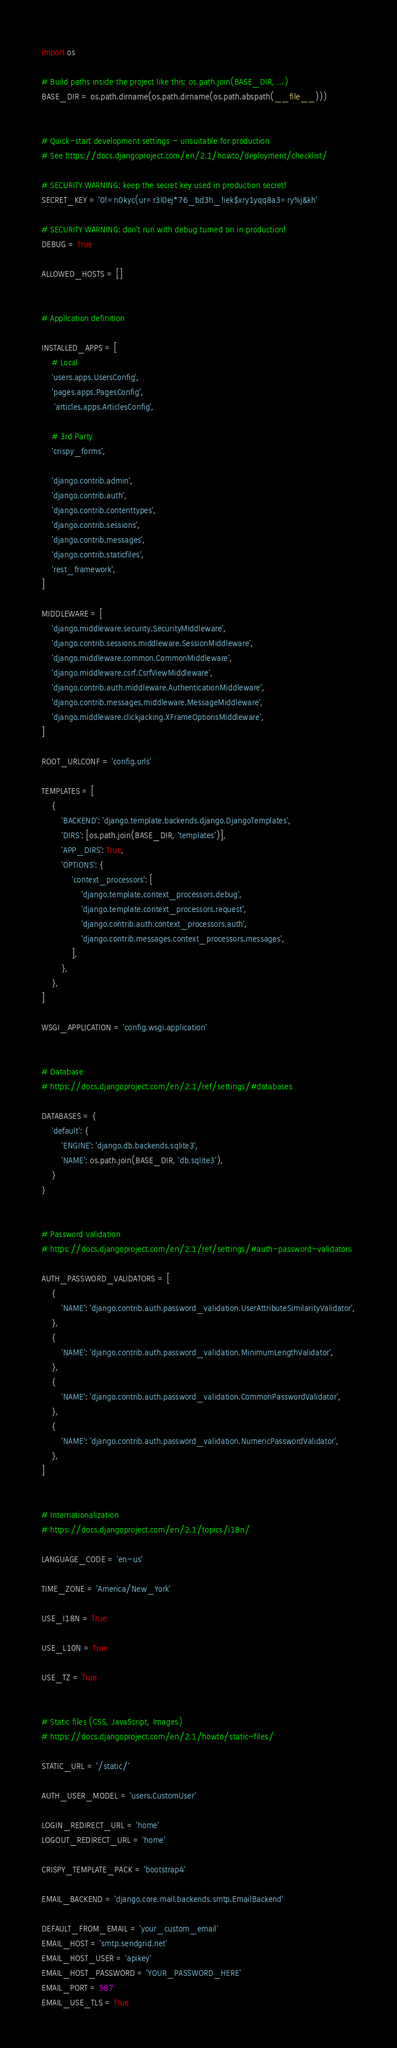Convert code to text. <code><loc_0><loc_0><loc_500><loc_500><_Python_>import os

# Build paths inside the project like this: os.path.join(BASE_DIR, ...)
BASE_DIR = os.path.dirname(os.path.dirname(os.path.abspath(__file__)))


# Quick-start development settings - unsuitable for production
# See https://docs.djangoproject.com/en/2.1/howto/deployment/checklist/

# SECURITY WARNING: keep the secret key used in production secret!
SECRET_KEY = '0!=n0kyc(ur=r3l0ej*76_bd3h_!iek$xry1yqq8a3=ry%j&kh'

# SECURITY WARNING: don't run with debug turned on in production!
DEBUG = True

ALLOWED_HOSTS = []


# Application definition

INSTALLED_APPS = [
    # Local
    'users.apps.UsersConfig',
    'pages.apps.PagesConfig',
     'articles.apps.ArticlesConfig',

    # 3rd Party
    'crispy_forms',

    'django.contrib.admin',
    'django.contrib.auth',
    'django.contrib.contenttypes',
    'django.contrib.sessions',
    'django.contrib.messages',
    'django.contrib.staticfiles',
    'rest_framework',
]

MIDDLEWARE = [
    'django.middleware.security.SecurityMiddleware',
    'django.contrib.sessions.middleware.SessionMiddleware',
    'django.middleware.common.CommonMiddleware',
    'django.middleware.csrf.CsrfViewMiddleware',
    'django.contrib.auth.middleware.AuthenticationMiddleware',
    'django.contrib.messages.middleware.MessageMiddleware',
    'django.middleware.clickjacking.XFrameOptionsMiddleware',
]

ROOT_URLCONF = 'config.urls'

TEMPLATES = [
    {
        'BACKEND': 'django.template.backends.django.DjangoTemplates',
        'DIRS': [os.path.join(BASE_DIR, 'templates')],
        'APP_DIRS': True,
        'OPTIONS': {
            'context_processors': [
                'django.template.context_processors.debug',
                'django.template.context_processors.request',
                'django.contrib.auth.context_processors.auth',
                'django.contrib.messages.context_processors.messages',
            ],
        },
    },
]

WSGI_APPLICATION = 'config.wsgi.application'


# Database
# https://docs.djangoproject.com/en/2.1/ref/settings/#databases

DATABASES = {
    'default': {
        'ENGINE': 'django.db.backends.sqlite3',
        'NAME': os.path.join(BASE_DIR, 'db.sqlite3'),
    }
}


# Password validation
# https://docs.djangoproject.com/en/2.1/ref/settings/#auth-password-validators

AUTH_PASSWORD_VALIDATORS = [
    {
        'NAME': 'django.contrib.auth.password_validation.UserAttributeSimilarityValidator',
    },
    {
        'NAME': 'django.contrib.auth.password_validation.MinimumLengthValidator',
    },
    {
        'NAME': 'django.contrib.auth.password_validation.CommonPasswordValidator',
    },
    {
        'NAME': 'django.contrib.auth.password_validation.NumericPasswordValidator',
    },
]


# Internationalization
# https://docs.djangoproject.com/en/2.1/topics/i18n/

LANGUAGE_CODE = 'en-us'

TIME_ZONE = 'America/New_York'

USE_I18N = True

USE_L10N = True

USE_TZ = True


# Static files (CSS, JavaScript, Images)
# https://docs.djangoproject.com/en/2.1/howto/static-files/

STATIC_URL = '/static/'

AUTH_USER_MODEL = 'users.CustomUser'

LOGIN_REDIRECT_URL = 'home'
LOGOUT_REDIRECT_URL = 'home'

CRISPY_TEMPLATE_PACK = 'bootstrap4'

EMAIL_BACKEND = 'django.core.mail.backends.smtp.EmailBackend'

DEFAULT_FROM_EMAIL = 'your_custom_email'
EMAIL_HOST = 'smtp.sendgrid.net'
EMAIL_HOST_USER = 'apikey'
EMAIL_HOST_PASSWORD = 'YOUR_PASSWORD_HERE'
EMAIL_PORT = 587
EMAIL_USE_TLS = True
</code> 